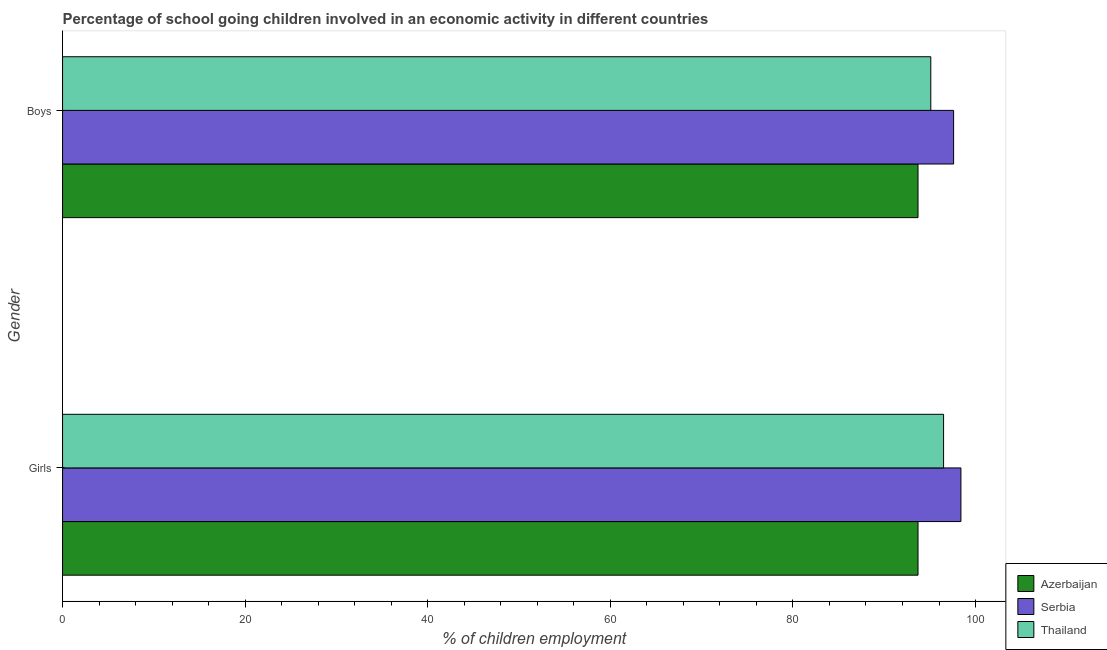How many groups of bars are there?
Offer a very short reply. 2. Are the number of bars per tick equal to the number of legend labels?
Provide a succinct answer. Yes. How many bars are there on the 2nd tick from the top?
Give a very brief answer. 3. How many bars are there on the 2nd tick from the bottom?
Your answer should be very brief. 3. What is the label of the 1st group of bars from the top?
Make the answer very short. Boys. What is the percentage of school going girls in Azerbaijan?
Your answer should be very brief. 93.7. Across all countries, what is the maximum percentage of school going boys?
Provide a short and direct response. 97.6. Across all countries, what is the minimum percentage of school going boys?
Ensure brevity in your answer.  93.7. In which country was the percentage of school going girls maximum?
Offer a terse response. Serbia. In which country was the percentage of school going boys minimum?
Provide a succinct answer. Azerbaijan. What is the total percentage of school going girls in the graph?
Your response must be concise. 288.6. What is the difference between the percentage of school going boys in Azerbaijan and that in Serbia?
Your answer should be compact. -3.9. What is the difference between the percentage of school going boys in Thailand and the percentage of school going girls in Serbia?
Provide a short and direct response. -3.3. What is the average percentage of school going boys per country?
Keep it short and to the point. 95.47. What is the difference between the percentage of school going girls and percentage of school going boys in Azerbaijan?
Make the answer very short. 0. What is the ratio of the percentage of school going boys in Thailand to that in Azerbaijan?
Your answer should be very brief. 1.01. Is the percentage of school going boys in Thailand less than that in Serbia?
Your answer should be very brief. Yes. What does the 2nd bar from the top in Boys represents?
Make the answer very short. Serbia. What does the 2nd bar from the bottom in Girls represents?
Keep it short and to the point. Serbia. How many bars are there?
Offer a very short reply. 6. What is the difference between two consecutive major ticks on the X-axis?
Provide a short and direct response. 20. Are the values on the major ticks of X-axis written in scientific E-notation?
Ensure brevity in your answer.  No. Does the graph contain any zero values?
Provide a short and direct response. No. Does the graph contain grids?
Ensure brevity in your answer.  No. Where does the legend appear in the graph?
Give a very brief answer. Bottom right. What is the title of the graph?
Your response must be concise. Percentage of school going children involved in an economic activity in different countries. What is the label or title of the X-axis?
Your answer should be very brief. % of children employment. What is the label or title of the Y-axis?
Ensure brevity in your answer.  Gender. What is the % of children employment in Azerbaijan in Girls?
Your answer should be compact. 93.7. What is the % of children employment in Serbia in Girls?
Ensure brevity in your answer.  98.4. What is the % of children employment of Thailand in Girls?
Provide a succinct answer. 96.5. What is the % of children employment in Azerbaijan in Boys?
Your answer should be very brief. 93.7. What is the % of children employment of Serbia in Boys?
Give a very brief answer. 97.6. What is the % of children employment of Thailand in Boys?
Give a very brief answer. 95.1. Across all Gender, what is the maximum % of children employment in Azerbaijan?
Your answer should be compact. 93.7. Across all Gender, what is the maximum % of children employment in Serbia?
Ensure brevity in your answer.  98.4. Across all Gender, what is the maximum % of children employment in Thailand?
Provide a succinct answer. 96.5. Across all Gender, what is the minimum % of children employment of Azerbaijan?
Provide a succinct answer. 93.7. Across all Gender, what is the minimum % of children employment of Serbia?
Your response must be concise. 97.6. Across all Gender, what is the minimum % of children employment of Thailand?
Ensure brevity in your answer.  95.1. What is the total % of children employment in Azerbaijan in the graph?
Make the answer very short. 187.4. What is the total % of children employment in Serbia in the graph?
Give a very brief answer. 196. What is the total % of children employment of Thailand in the graph?
Your response must be concise. 191.6. What is the difference between the % of children employment of Azerbaijan in Girls and that in Boys?
Make the answer very short. 0. What is the difference between the % of children employment of Serbia in Girls and that in Boys?
Offer a very short reply. 0.8. What is the difference between the % of children employment of Thailand in Girls and that in Boys?
Make the answer very short. 1.4. What is the difference between the % of children employment in Azerbaijan in Girls and the % of children employment in Thailand in Boys?
Keep it short and to the point. -1.4. What is the difference between the % of children employment of Serbia in Girls and the % of children employment of Thailand in Boys?
Keep it short and to the point. 3.3. What is the average % of children employment in Azerbaijan per Gender?
Offer a terse response. 93.7. What is the average % of children employment in Thailand per Gender?
Your answer should be very brief. 95.8. What is the difference between the % of children employment in Azerbaijan and % of children employment in Thailand in Girls?
Your answer should be compact. -2.8. What is the difference between the % of children employment in Azerbaijan and % of children employment in Thailand in Boys?
Your answer should be compact. -1.4. What is the ratio of the % of children employment in Serbia in Girls to that in Boys?
Provide a short and direct response. 1.01. What is the ratio of the % of children employment in Thailand in Girls to that in Boys?
Provide a succinct answer. 1.01. What is the difference between the highest and the second highest % of children employment in Azerbaijan?
Offer a terse response. 0. What is the difference between the highest and the lowest % of children employment in Serbia?
Provide a short and direct response. 0.8. What is the difference between the highest and the lowest % of children employment in Thailand?
Ensure brevity in your answer.  1.4. 